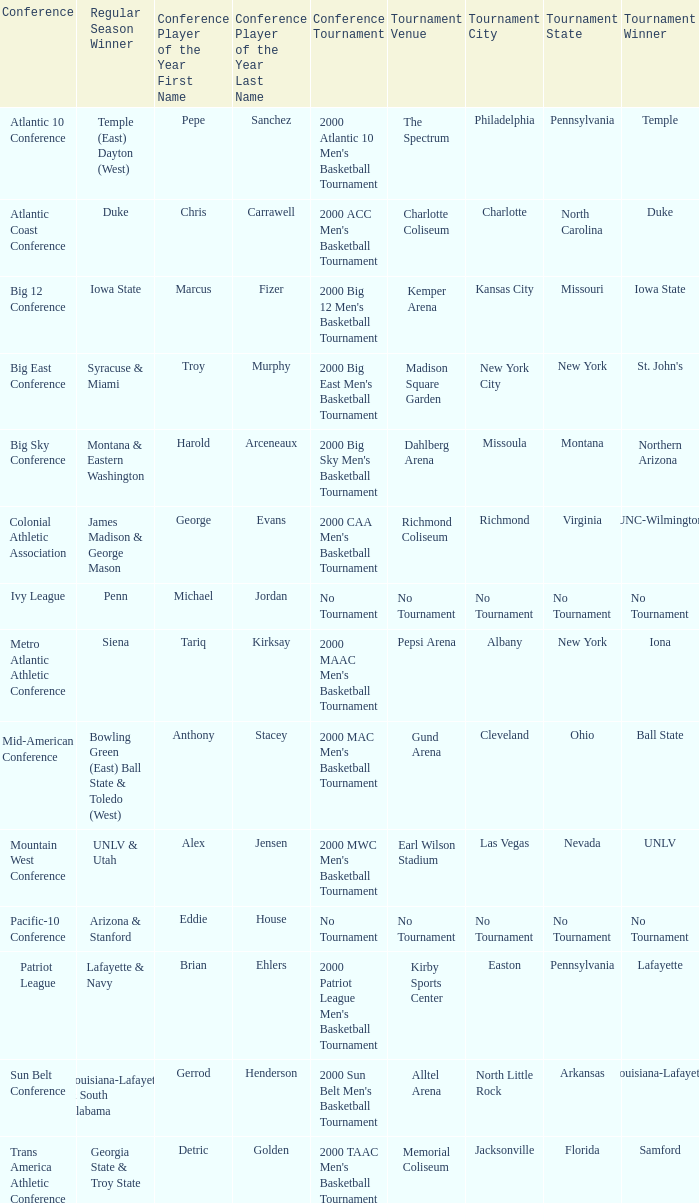What is the venue and city where the 2000 MWC Men's Basketball Tournament? Earl Wilson Stadium ( Las Vegas, Nevada ). 